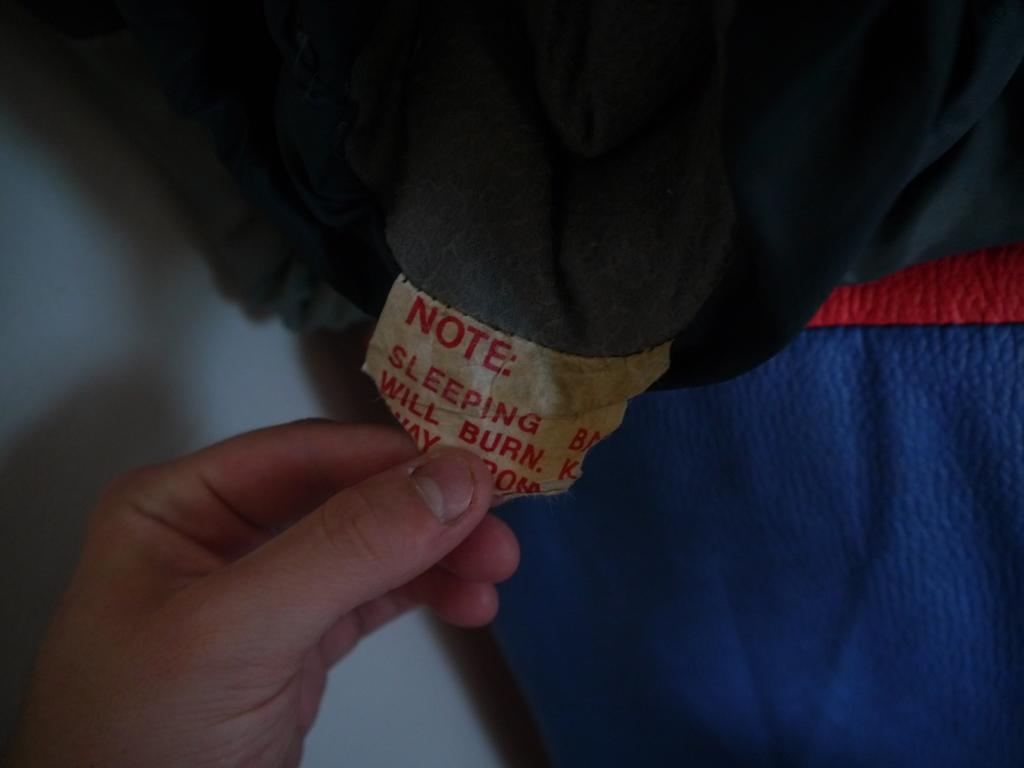How would you summarize this image in a sentence or two? At the bottom of the image there is a person's hand holding a tag of the cloth. 